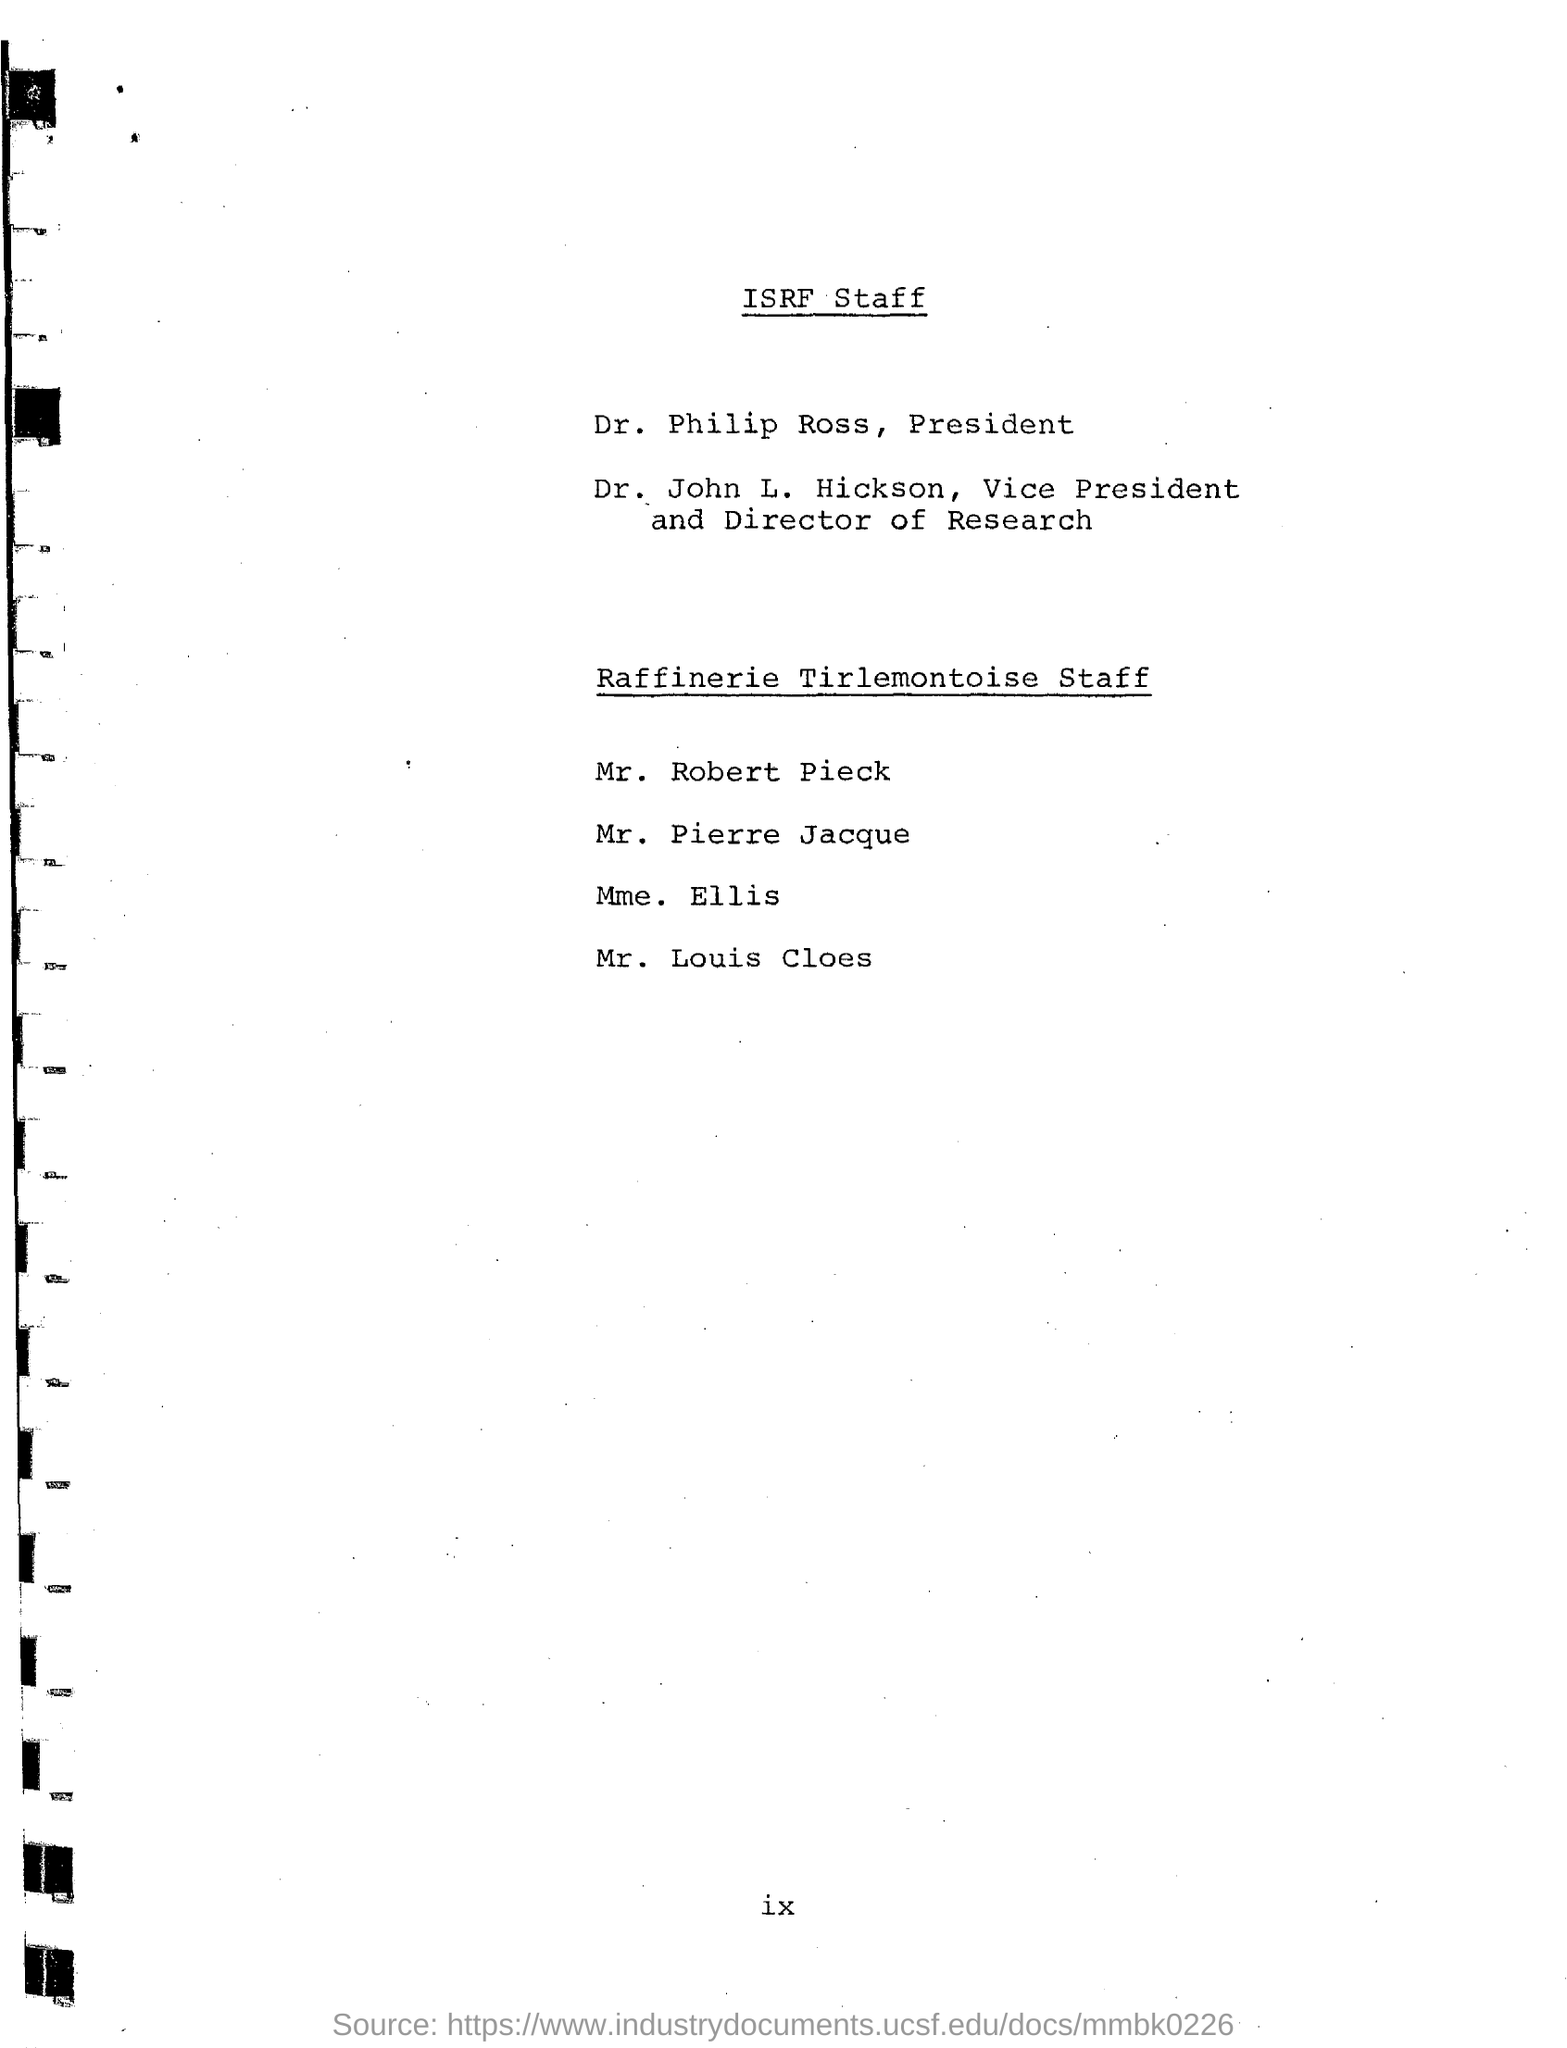Point out several critical features in this image. Dr. Philip Ross is the President. Dr. John L. Hickson is the Vice President and Director of Research. 